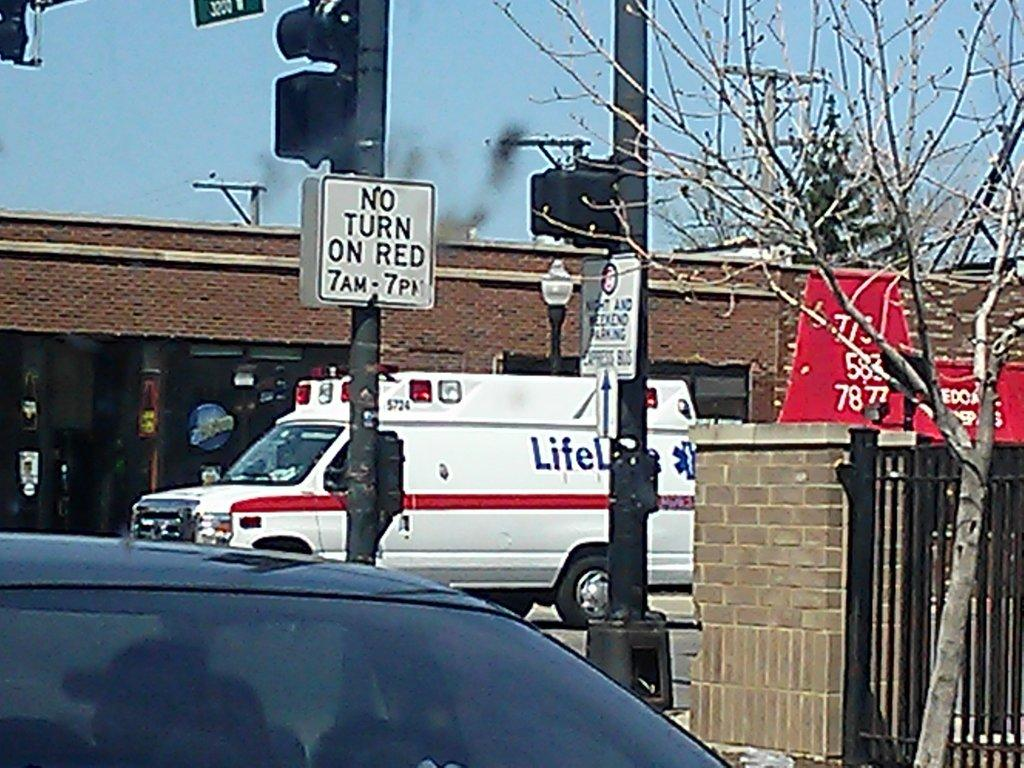What types of objects are in the image? There are vehicles, caution boards, traffic signals, a wall, a gate, a building, and trees in the image. What might be used to control traffic in the image? Traffic signals are visible in the image for controlling traffic. What architectural feature is present in the image? There is a gate in the image. What is visible in the background of the image? The sky is visible in the background of the image. What theory is being presented on the stage in the image? There is no stage present in the image, so no theory can be presented. Where is the drawer located in the image? There is no drawer present in the image. 